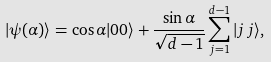<formula> <loc_0><loc_0><loc_500><loc_500>| \psi ( \alpha ) \rangle = \cos \alpha | 0 0 \rangle + \frac { \sin \alpha } { \sqrt { d - 1 } } \sum ^ { d - 1 } _ { j = 1 } | j \, j \rangle ,</formula> 